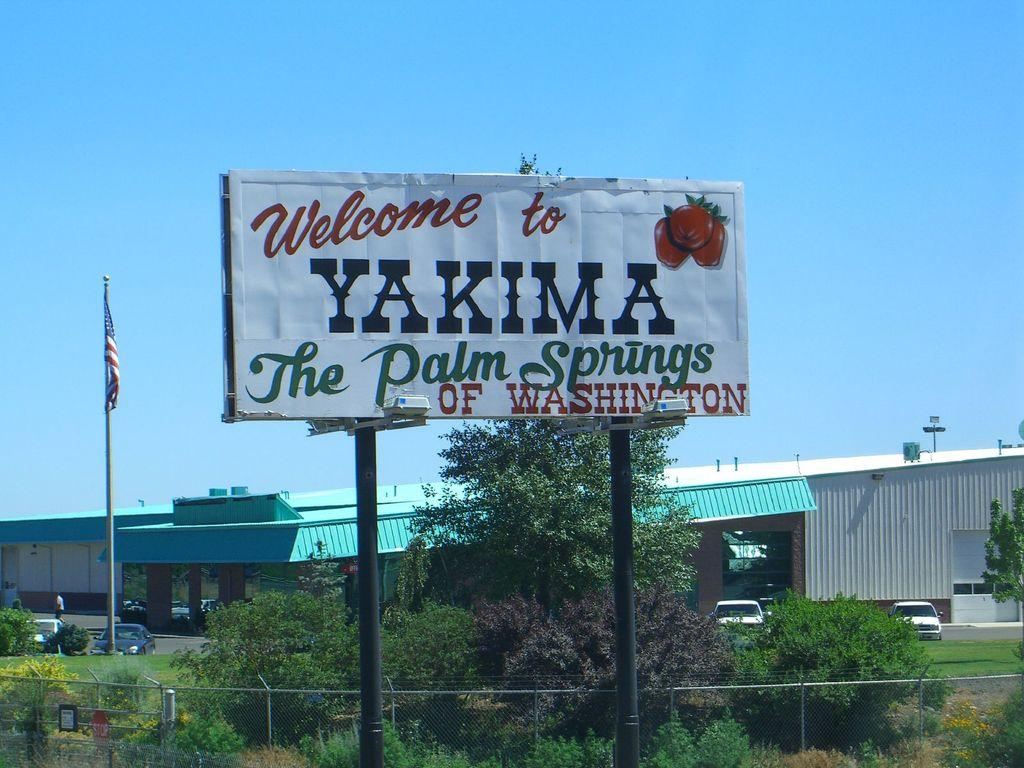<image>
Give a short and clear explanation of the subsequent image. A large sign by the roadise that welcomes us to Yakima, the Palm Springs of Washington. 